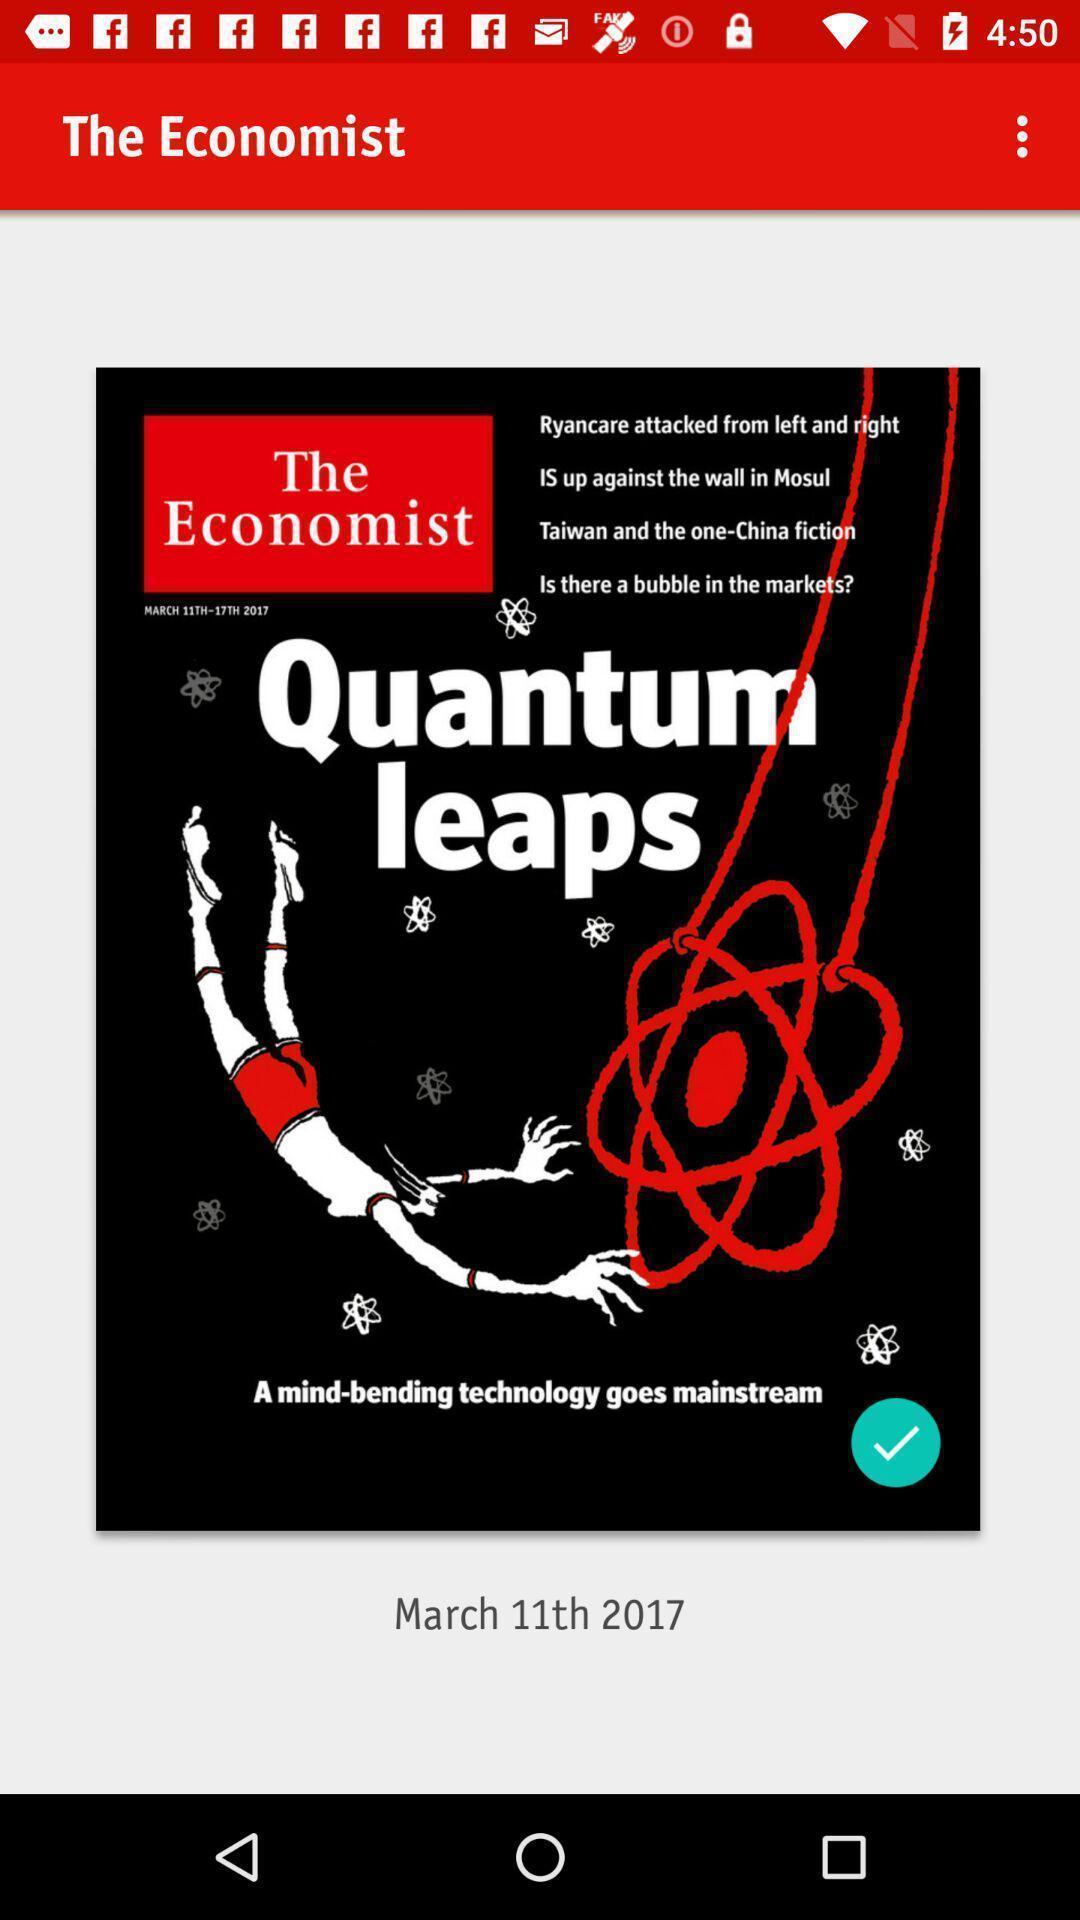Tell me what you see in this picture. Welcome page. 